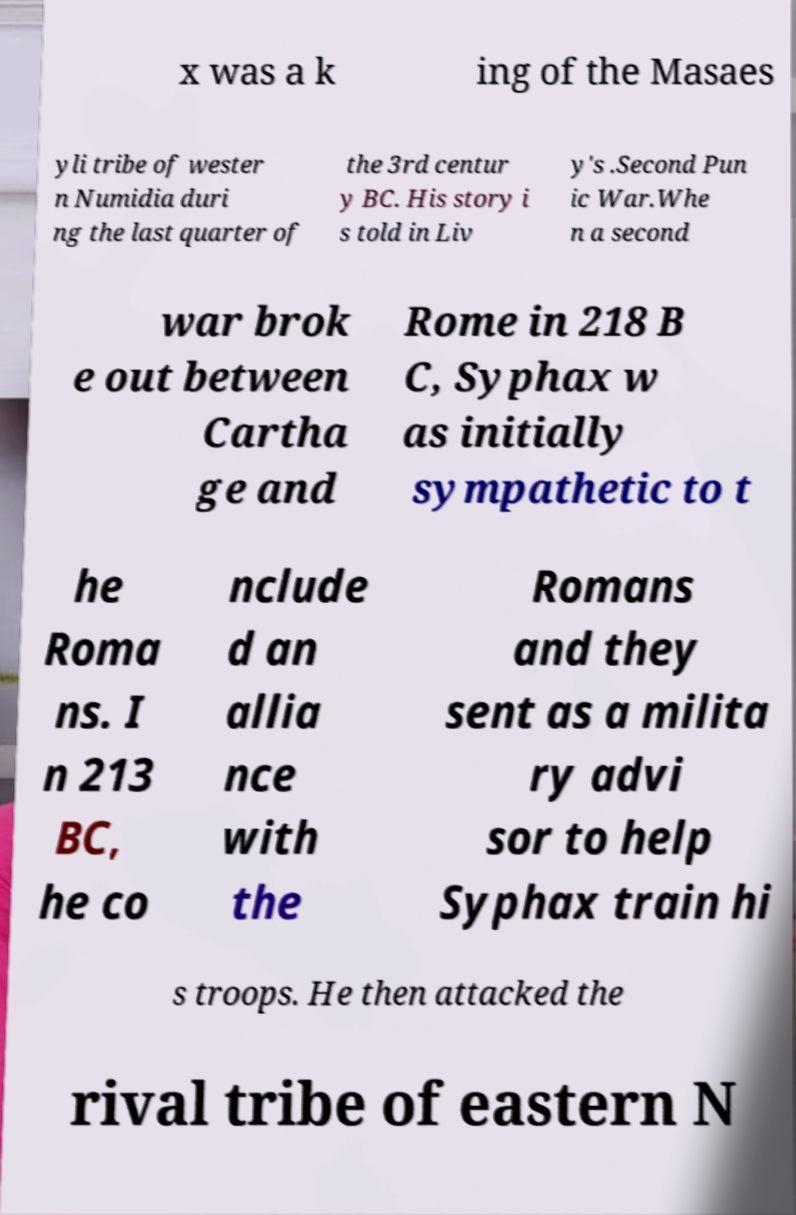Could you extract and type out the text from this image? x was a k ing of the Masaes yli tribe of wester n Numidia duri ng the last quarter of the 3rd centur y BC. His story i s told in Liv y's .Second Pun ic War.Whe n a second war brok e out between Cartha ge and Rome in 218 B C, Syphax w as initially sympathetic to t he Roma ns. I n 213 BC, he co nclude d an allia nce with the Romans and they sent as a milita ry advi sor to help Syphax train hi s troops. He then attacked the rival tribe of eastern N 